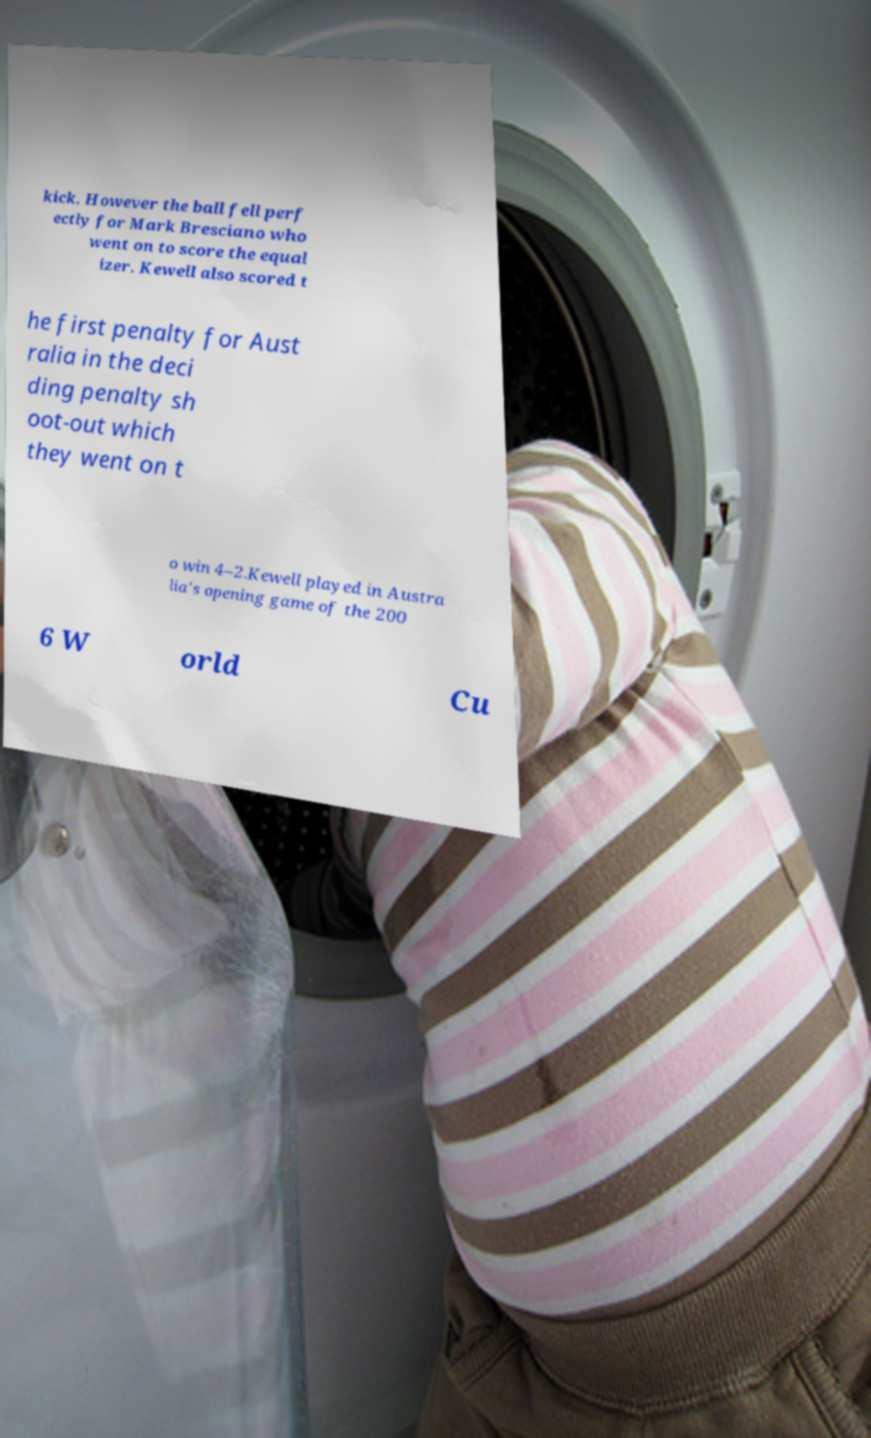Can you accurately transcribe the text from the provided image for me? kick. However the ball fell perf ectly for Mark Bresciano who went on to score the equal izer. Kewell also scored t he first penalty for Aust ralia in the deci ding penalty sh oot-out which they went on t o win 4–2.Kewell played in Austra lia's opening game of the 200 6 W orld Cu 